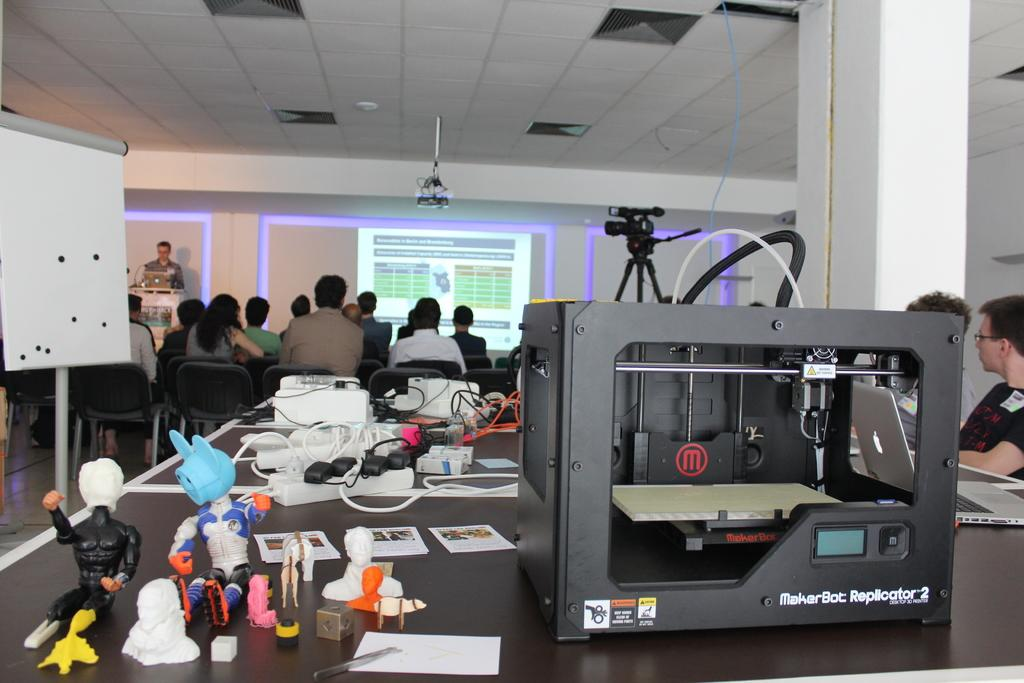<image>
Share a concise interpretation of the image provided. A Marker Bot Replicator 2 machine sitting on a table behind a group of people in a room sitting down. 